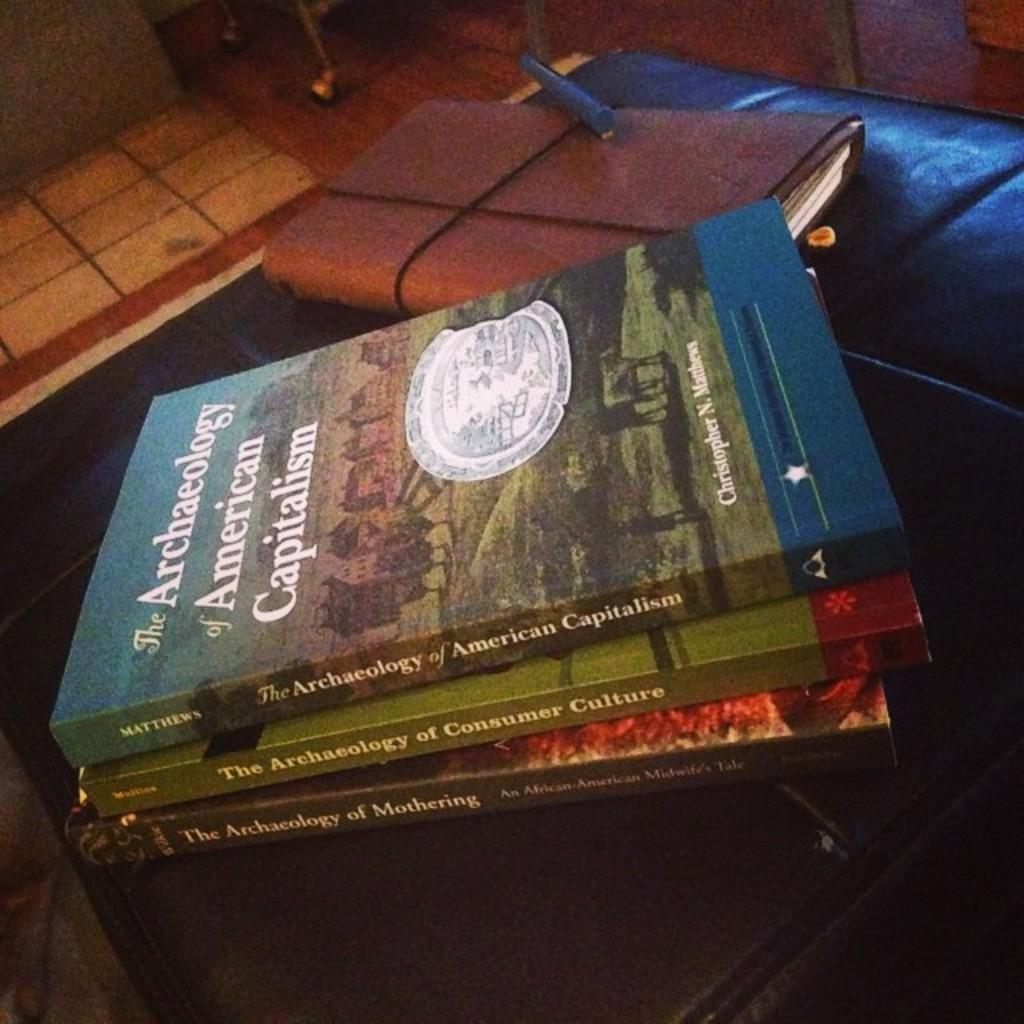<image>
Present a compact description of the photo's key features. The book The Archaeology of American Capitalism is sitting with other books on the ottoman. 